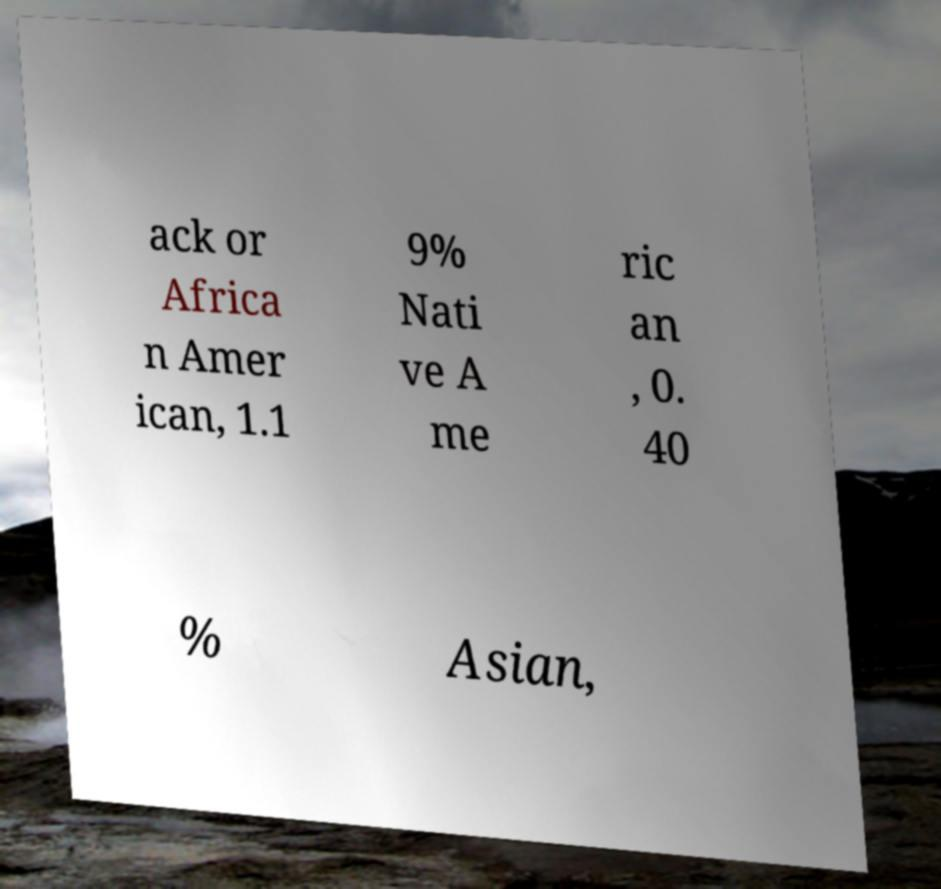What messages or text are displayed in this image? I need them in a readable, typed format. ack or Africa n Amer ican, 1.1 9% Nati ve A me ric an , 0. 40 % Asian, 